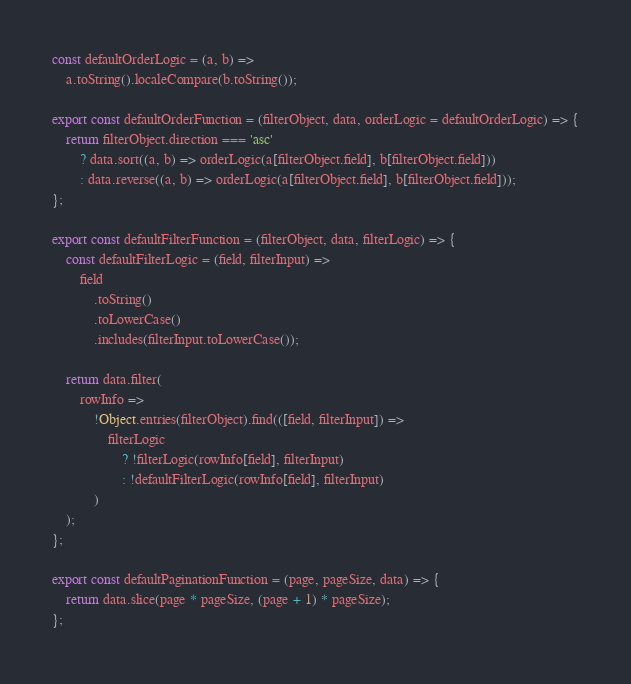Convert code to text. <code><loc_0><loc_0><loc_500><loc_500><_JavaScript_>const defaultOrderLogic = (a, b) =>
    a.toString().localeCompare(b.toString());

export const defaultOrderFunction = (filterObject, data, orderLogic = defaultOrderLogic) => {
    return filterObject.direction === 'asc'
        ? data.sort((a, b) => orderLogic(a[filterObject.field], b[filterObject.field]))
        : data.reverse((a, b) => orderLogic(a[filterObject.field], b[filterObject.field]));
};

export const defaultFilterFunction = (filterObject, data, filterLogic) => {
    const defaultFilterLogic = (field, filterInput) =>
        field
            .toString()
            .toLowerCase()
            .includes(filterInput.toLowerCase());

    return data.filter(
        rowInfo =>
            !Object.entries(filterObject).find(([field, filterInput]) =>
                filterLogic
                    ? !filterLogic(rowInfo[field], filterInput)
                    : !defaultFilterLogic(rowInfo[field], filterInput)
            )
    );
};

export const defaultPaginationFunction = (page, pageSize, data) => {
    return data.slice(page * pageSize, (page + 1) * pageSize);
};
</code> 